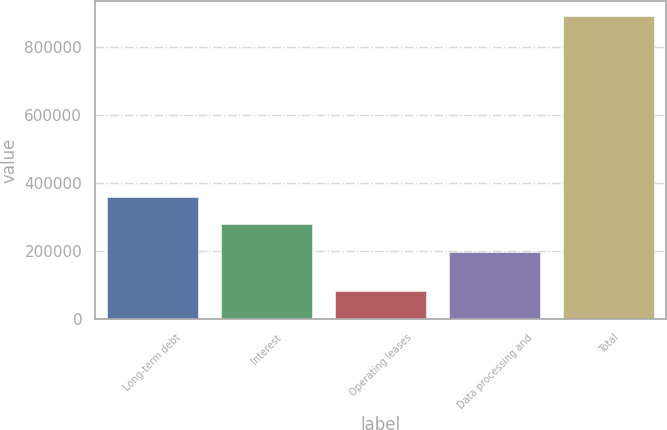Convert chart. <chart><loc_0><loc_0><loc_500><loc_500><bar_chart><fcel>Long-term debt<fcel>Interest<fcel>Operating leases<fcel>Data processing and<fcel>Total<nl><fcel>359450<fcel>278870<fcel>83382<fcel>198290<fcel>889180<nl></chart> 